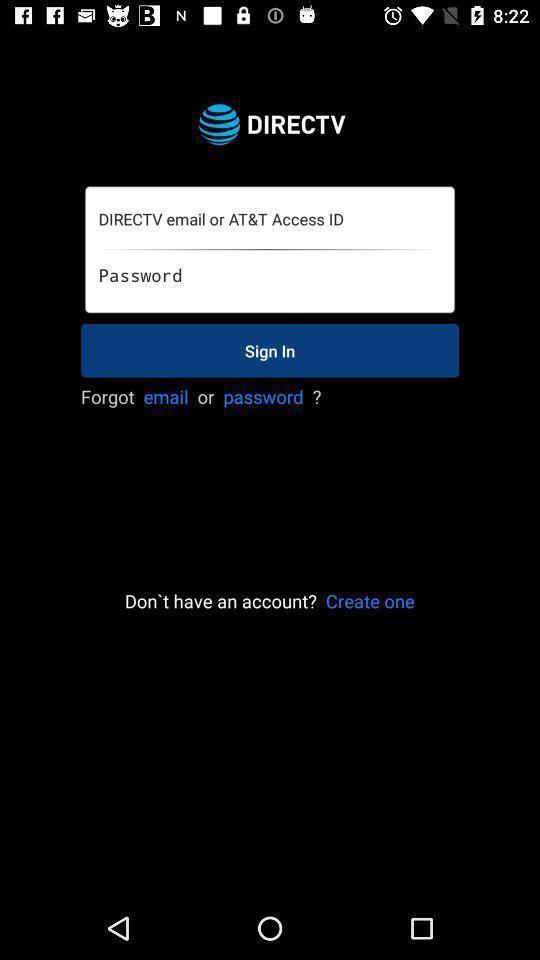What can you discern from this picture? Welcome page with sign in option. 